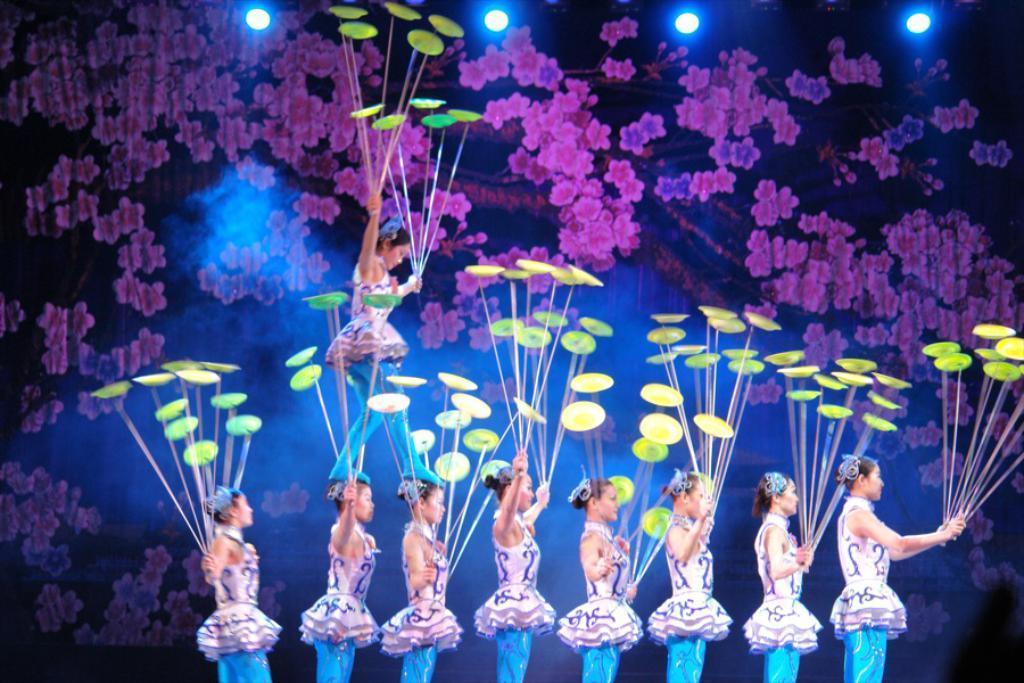In one or two sentences, can you explain what this image depicts? In this picture I can see group of people standing and performing plate spinning, and in the background there are focus lights and a curtain. 